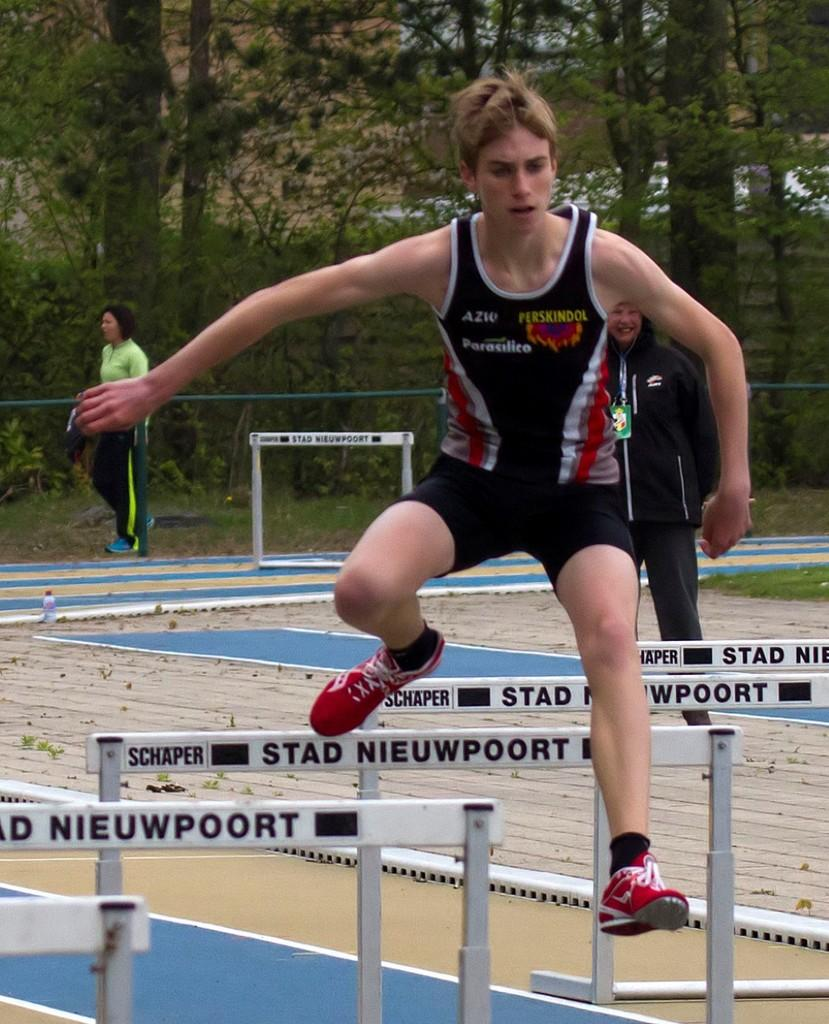<image>
Describe the image concisely. a running jersey that has perskindol written on it 